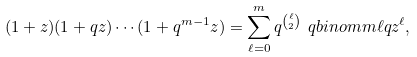Convert formula to latex. <formula><loc_0><loc_0><loc_500><loc_500>( 1 + z ) ( 1 + q z ) \cdots ( 1 + q ^ { m - 1 } z ) = \sum _ { \ell = 0 } ^ { m } q ^ { \binom { \ell } { 2 } } \ q b i n o m m \ell q z ^ { \ell } ,</formula> 